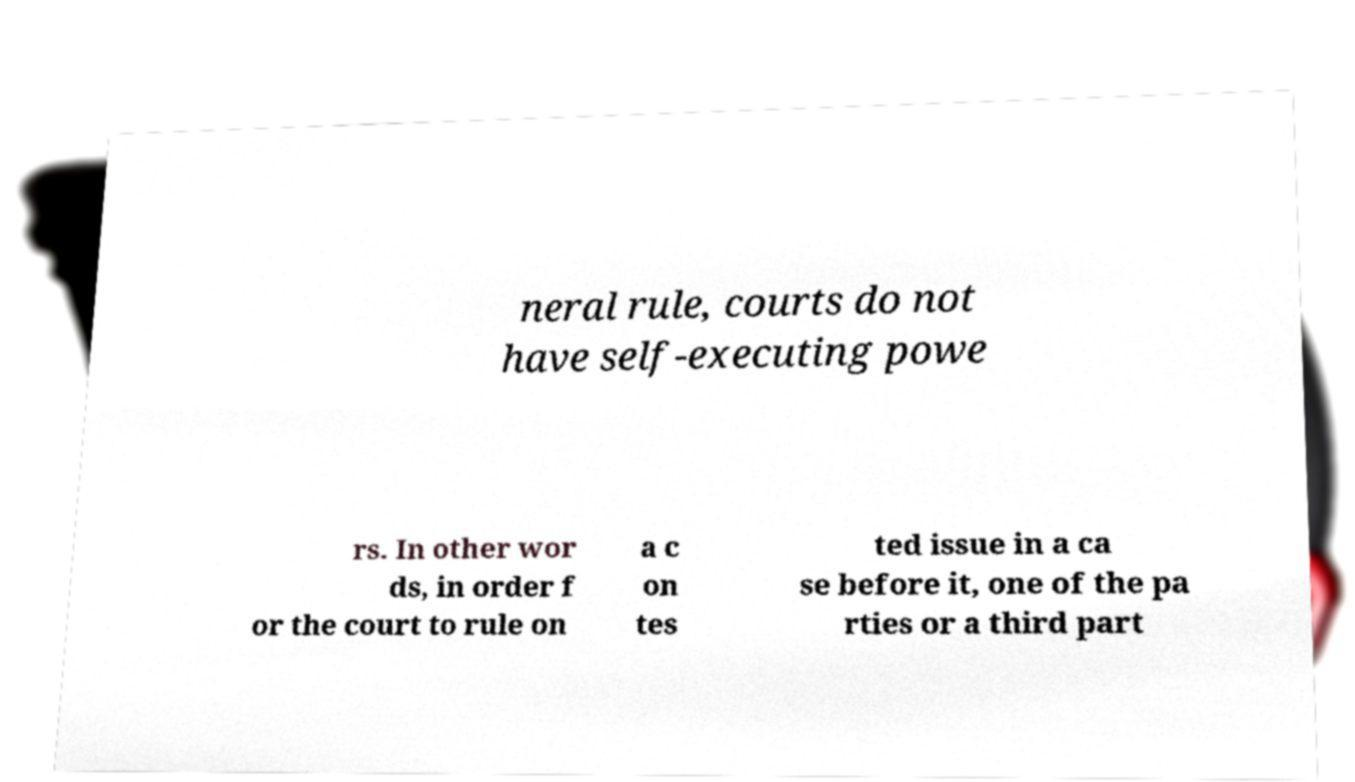Can you accurately transcribe the text from the provided image for me? neral rule, courts do not have self-executing powe rs. In other wor ds, in order f or the court to rule on a c on tes ted issue in a ca se before it, one of the pa rties or a third part 